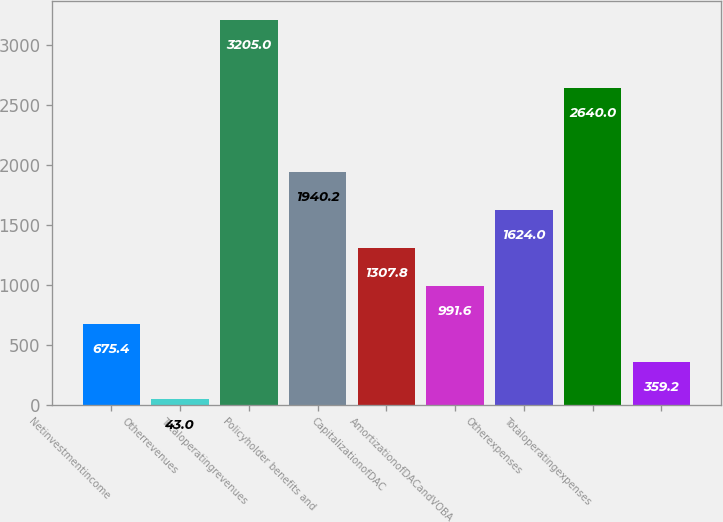Convert chart. <chart><loc_0><loc_0><loc_500><loc_500><bar_chart><fcel>Netinvestmentincome<fcel>Otherrevenues<fcel>Totaloperatingrevenues<fcel>Policyholder benefits and<fcel>CapitalizationofDAC<fcel>AmortizationofDACandVOBA<fcel>Otherexpenses<fcel>Totaloperatingexpenses<fcel>Unnamed: 8<nl><fcel>675.4<fcel>43<fcel>3205<fcel>1940.2<fcel>1307.8<fcel>991.6<fcel>1624<fcel>2640<fcel>359.2<nl></chart> 